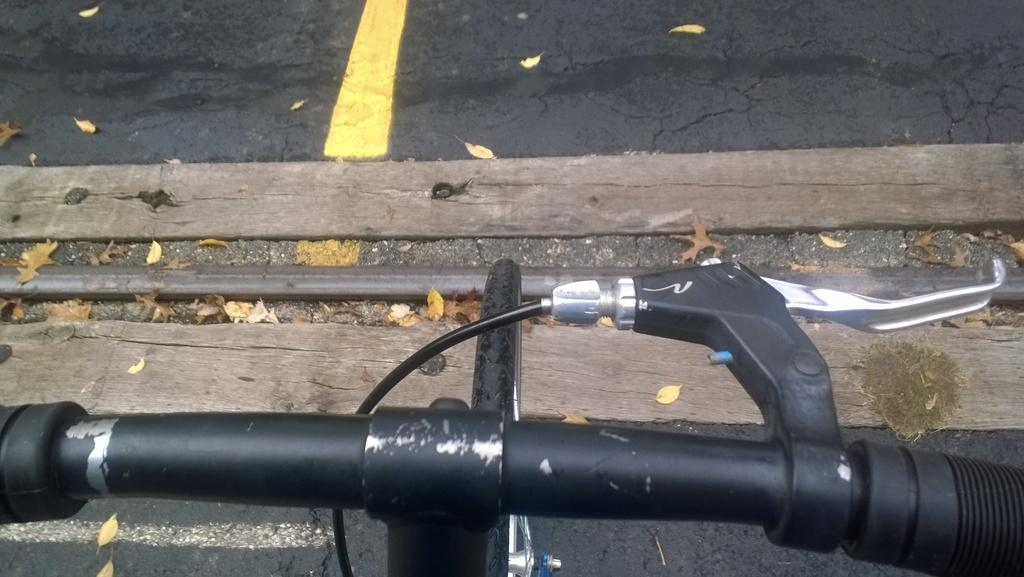What is: What is the main object in the foreground of the image? There is a bicycle in the foreground of the image. What type of setting is depicted in the image? The image depicts a road. What can be seen on the ground in the image? Dried leaves are present on the ground in the image. Where is the cave located in the image? There is no cave present in the image. What type of nut can be seen growing on the side of the road in the image? There are no nuts present in the image. 